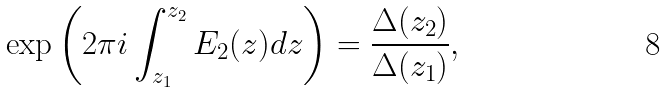<formula> <loc_0><loc_0><loc_500><loc_500>\exp \left ( 2 \pi i \int ^ { z _ { 2 } } _ { z _ { 1 } } E _ { 2 } ( z ) d z \right ) = \frac { \Delta ( z _ { 2 } ) } { \Delta ( z _ { 1 } ) } ,</formula> 